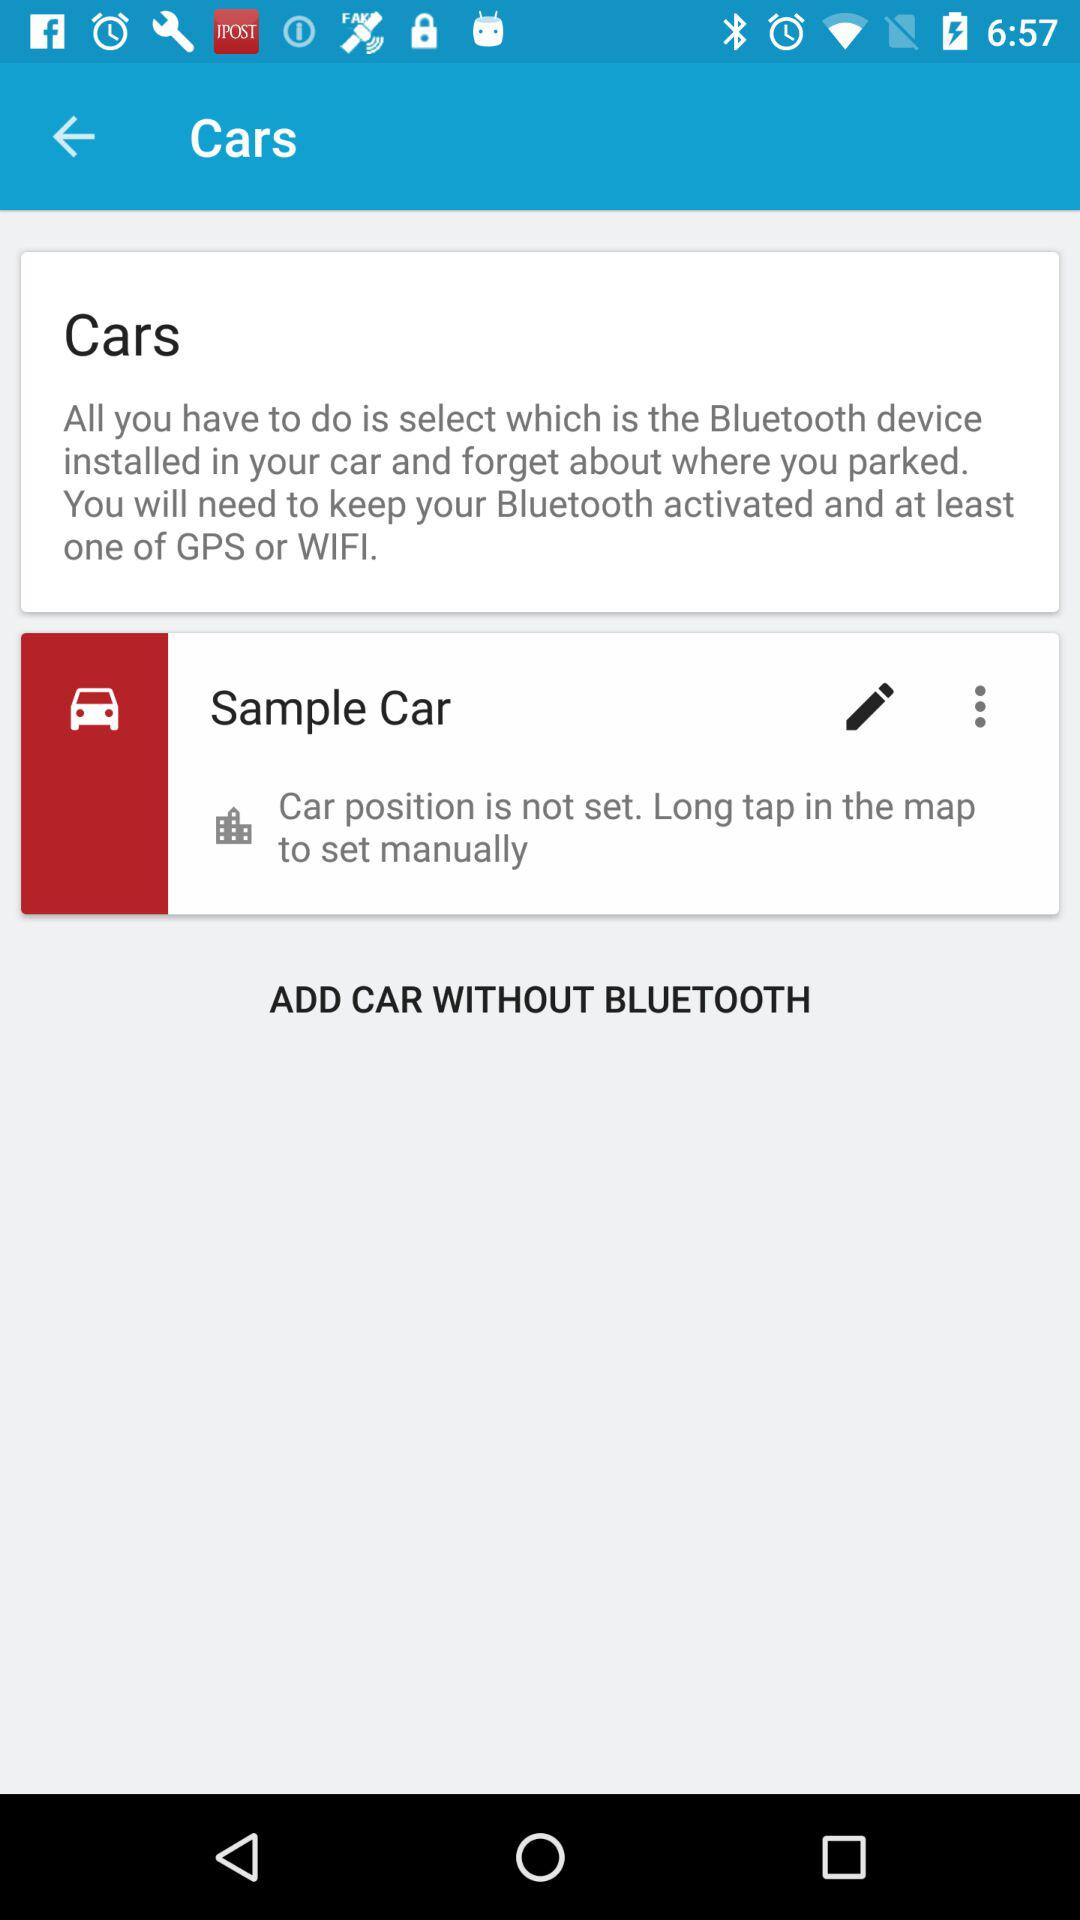Can we add car with bluetooth?
When the provided information is insufficient, respond with <no answer>. <no answer> 